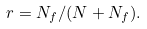Convert formula to latex. <formula><loc_0><loc_0><loc_500><loc_500>r = N _ { f } / ( N + N _ { f } ) .</formula> 